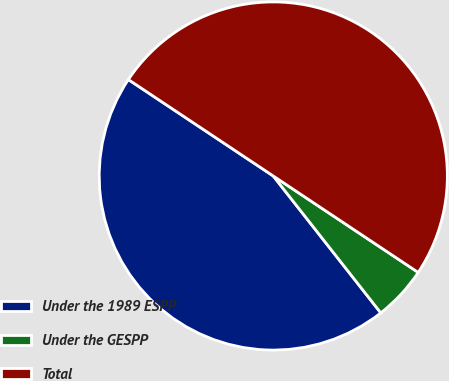Convert chart. <chart><loc_0><loc_0><loc_500><loc_500><pie_chart><fcel>Under the 1989 ESPP<fcel>Under the GESPP<fcel>Total<nl><fcel>44.94%<fcel>5.06%<fcel>50.0%<nl></chart> 